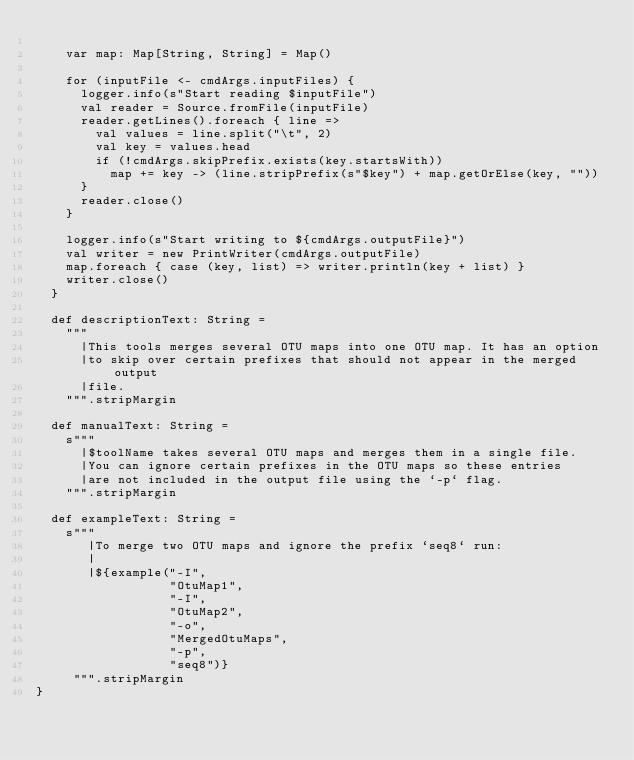<code> <loc_0><loc_0><loc_500><loc_500><_Scala_>
    var map: Map[String, String] = Map()

    for (inputFile <- cmdArgs.inputFiles) {
      logger.info(s"Start reading $inputFile")
      val reader = Source.fromFile(inputFile)
      reader.getLines().foreach { line =>
        val values = line.split("\t", 2)
        val key = values.head
        if (!cmdArgs.skipPrefix.exists(key.startsWith))
          map += key -> (line.stripPrefix(s"$key") + map.getOrElse(key, ""))
      }
      reader.close()
    }

    logger.info(s"Start writing to ${cmdArgs.outputFile}")
    val writer = new PrintWriter(cmdArgs.outputFile)
    map.foreach { case (key, list) => writer.println(key + list) }
    writer.close()
  }

  def descriptionText: String =
    """
      |This tools merges several OTU maps into one OTU map. It has an option
      |to skip over certain prefixes that should not appear in the merged output
      |file.
    """.stripMargin

  def manualText: String =
    s"""
      |$toolName takes several OTU maps and merges them in a single file.
      |You can ignore certain prefixes in the OTU maps so these entries
      |are not included in the output file using the `-p` flag.
    """.stripMargin

  def exampleText: String =
    s"""
       |To merge two OTU maps and ignore the prefix `seq8` run:
       |
       |${example("-I",
                  "OtuMap1",
                  "-I",
                  "OtuMap2",
                  "-o",
                  "MergedOtuMaps",
                  "-p",
                  "seq8")}
     """.stripMargin
}
</code> 